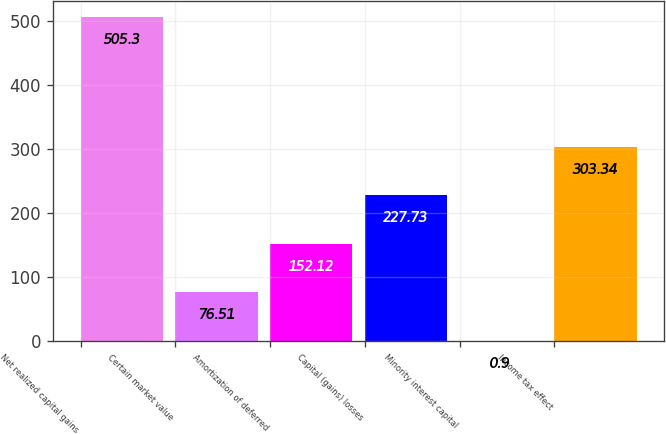Convert chart. <chart><loc_0><loc_0><loc_500><loc_500><bar_chart><fcel>Net realized capital gains<fcel>Certain market value<fcel>Amortization of deferred<fcel>Capital (gains) losses<fcel>Minority interest capital<fcel>Income tax effect<nl><fcel>505.3<fcel>76.51<fcel>152.12<fcel>227.73<fcel>0.9<fcel>303.34<nl></chart> 